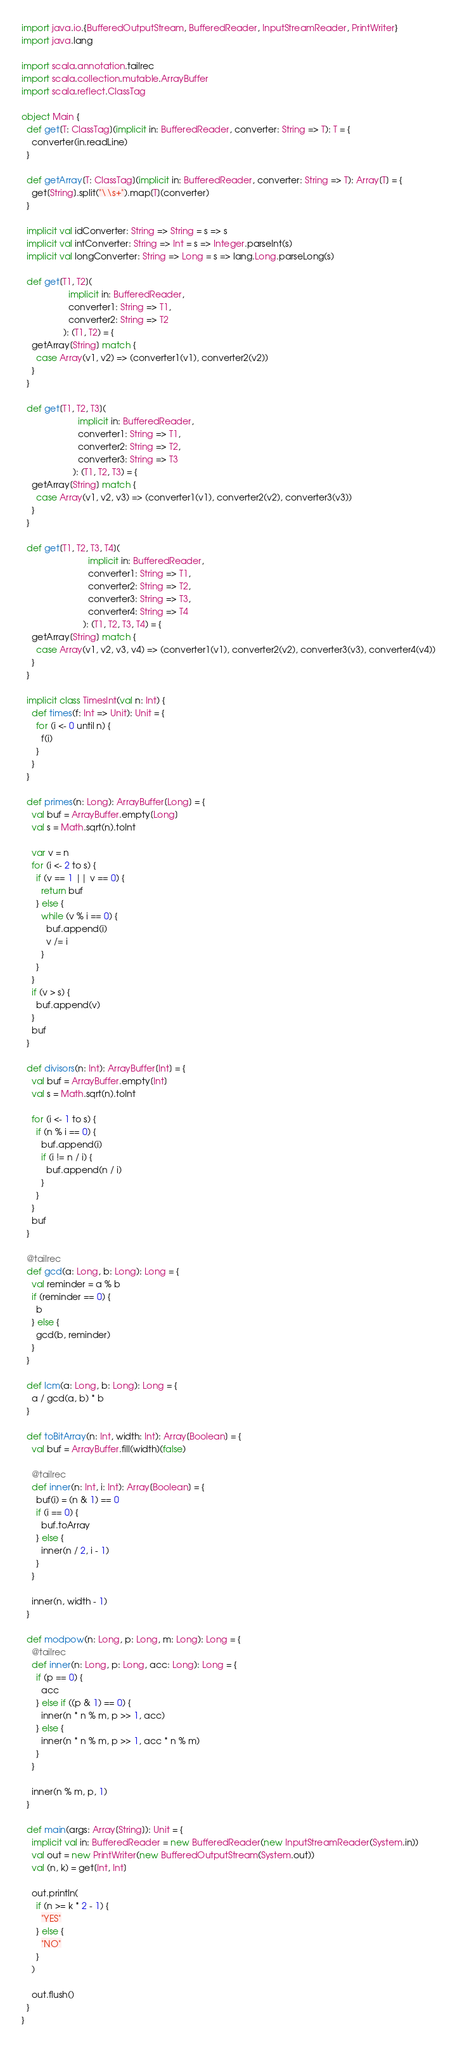Convert code to text. <code><loc_0><loc_0><loc_500><loc_500><_Scala_>import java.io.{BufferedOutputStream, BufferedReader, InputStreamReader, PrintWriter}
import java.lang

import scala.annotation.tailrec
import scala.collection.mutable.ArrayBuffer
import scala.reflect.ClassTag

object Main {
  def get[T: ClassTag](implicit in: BufferedReader, converter: String => T): T = {
    converter(in.readLine)
  }

  def getArray[T: ClassTag](implicit in: BufferedReader, converter: String => T): Array[T] = {
    get[String].split("\\s+").map[T](converter)
  }

  implicit val idConverter: String => String = s => s
  implicit val intConverter: String => Int = s => Integer.parseInt(s)
  implicit val longConverter: String => Long = s => lang.Long.parseLong(s)

  def get[T1, T2](
                   implicit in: BufferedReader,
                   converter1: String => T1,
                   converter2: String => T2
                 ): (T1, T2) = {
    getArray[String] match {
      case Array(v1, v2) => (converter1(v1), converter2(v2))
    }
  }

  def get[T1, T2, T3](
                       implicit in: BufferedReader,
                       converter1: String => T1,
                       converter2: String => T2,
                       converter3: String => T3
                     ): (T1, T2, T3) = {
    getArray[String] match {
      case Array(v1, v2, v3) => (converter1(v1), converter2(v2), converter3(v3))
    }
  }

  def get[T1, T2, T3, T4](
                           implicit in: BufferedReader,
                           converter1: String => T1,
                           converter2: String => T2,
                           converter3: String => T3,
                           converter4: String => T4
                         ): (T1, T2, T3, T4) = {
    getArray[String] match {
      case Array(v1, v2, v3, v4) => (converter1(v1), converter2(v2), converter3(v3), converter4(v4))
    }
  }

  implicit class TimesInt(val n: Int) {
    def times(f: Int => Unit): Unit = {
      for (i <- 0 until n) {
        f(i)
      }
    }
  }

  def primes(n: Long): ArrayBuffer[Long] = {
    val buf = ArrayBuffer.empty[Long]
    val s = Math.sqrt(n).toInt

    var v = n
    for (i <- 2 to s) {
      if (v == 1 || v == 0) {
        return buf
      } else {
        while (v % i == 0) {
          buf.append(i)
          v /= i
        }
      }
    }
    if (v > s) {
      buf.append(v)
    }
    buf
  }

  def divisors(n: Int): ArrayBuffer[Int] = {
    val buf = ArrayBuffer.empty[Int]
    val s = Math.sqrt(n).toInt

    for (i <- 1 to s) {
      if (n % i == 0) {
        buf.append(i)
        if (i != n / i) {
          buf.append(n / i)
        }
      }
    }
    buf
  }

  @tailrec
  def gcd(a: Long, b: Long): Long = {
    val reminder = a % b
    if (reminder == 0) {
      b
    } else {
      gcd(b, reminder)
    }
  }

  def lcm(a: Long, b: Long): Long = {
    a / gcd(a, b) * b
  }

  def toBitArray(n: Int, width: Int): Array[Boolean] = {
    val buf = ArrayBuffer.fill(width)(false)

    @tailrec
    def inner(n: Int, i: Int): Array[Boolean] = {
      buf(i) = (n & 1) == 0
      if (i == 0) {
        buf.toArray
      } else {
        inner(n / 2, i - 1)
      }
    }

    inner(n, width - 1)
  }

  def modpow(n: Long, p: Long, m: Long): Long = {
    @tailrec
    def inner(n: Long, p: Long, acc: Long): Long = {
      if (p == 0) {
        acc
      } else if ((p & 1) == 0) {
        inner(n * n % m, p >> 1, acc)
      } else {
        inner(n * n % m, p >> 1, acc * n % m)
      }
    }

    inner(n % m, p, 1)
  }

  def main(args: Array[String]): Unit = {
    implicit val in: BufferedReader = new BufferedReader(new InputStreamReader(System.in))
    val out = new PrintWriter(new BufferedOutputStream(System.out))
    val (n, k) = get[Int, Int]

    out.println(
      if (n >= k * 2 - 1) {
        "YES"
      } else {
        "NO"
      }
    )

    out.flush()
  }
}</code> 